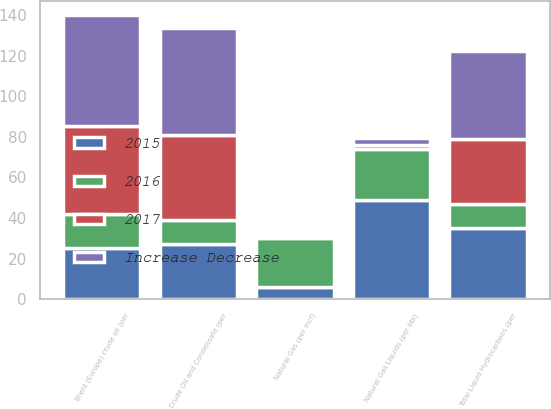Convert chart. <chart><loc_0><loc_0><loc_500><loc_500><stacked_bar_chart><ecel><fcel>Crude Oil and Condensate (per<fcel>Natural Gas Liquids (per bbl)<fcel>Total Liquid Hydrocarbons (per<fcel>Natural Gas (per mcf)<fcel>Brent (Europe) crude oil (per<nl><fcel>Increase Decrease<fcel>53.05<fcel>3.15<fcel>43.36<fcel>0.55<fcel>54.25<nl><fcel>2015<fcel>27<fcel>49<fcel>35<fcel>6<fcel>25<nl><fcel>2017<fcel>41.7<fcel>2.11<fcel>32.1<fcel>0.52<fcel>43.55<nl><fcel>2016<fcel>12<fcel>25<fcel>12<fcel>24<fcel>17<nl></chart> 